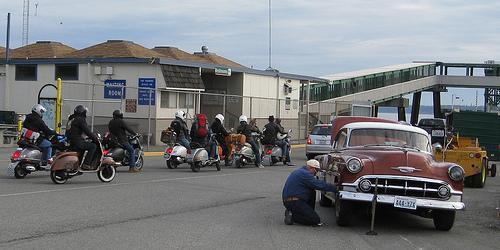How many are working?
Give a very brief answer. 1. How many roof peaks do not have a vent?
Give a very brief answer. 3. 